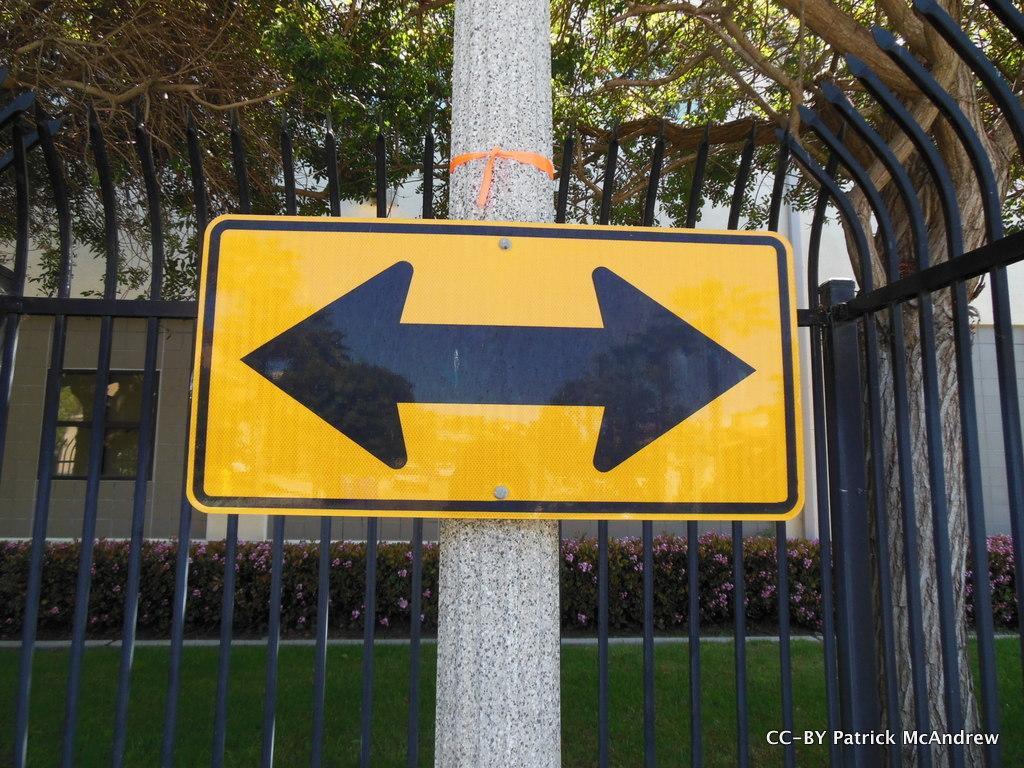How would you summarize this image in a sentence or two? This picture is clicked outside. In the center we can see a yellow color sign board attached to the trunk of a tree. In the background we can see the metal rods, green grass, flowers, plants, trees, buildings. In the bottom right corner we can see the text on the image. 